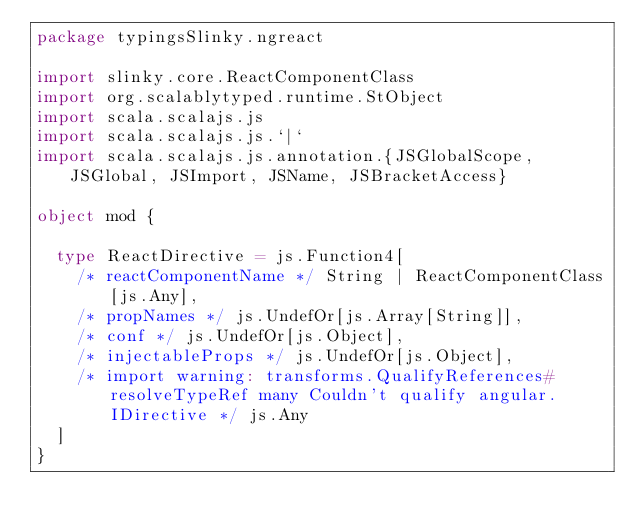<code> <loc_0><loc_0><loc_500><loc_500><_Scala_>package typingsSlinky.ngreact

import slinky.core.ReactComponentClass
import org.scalablytyped.runtime.StObject
import scala.scalajs.js
import scala.scalajs.js.`|`
import scala.scalajs.js.annotation.{JSGlobalScope, JSGlobal, JSImport, JSName, JSBracketAccess}

object mod {
  
  type ReactDirective = js.Function4[
    /* reactComponentName */ String | ReactComponentClass[js.Any], 
    /* propNames */ js.UndefOr[js.Array[String]], 
    /* conf */ js.UndefOr[js.Object], 
    /* injectableProps */ js.UndefOr[js.Object], 
    /* import warning: transforms.QualifyReferences#resolveTypeRef many Couldn't qualify angular.IDirective */ js.Any
  ]
}
</code> 